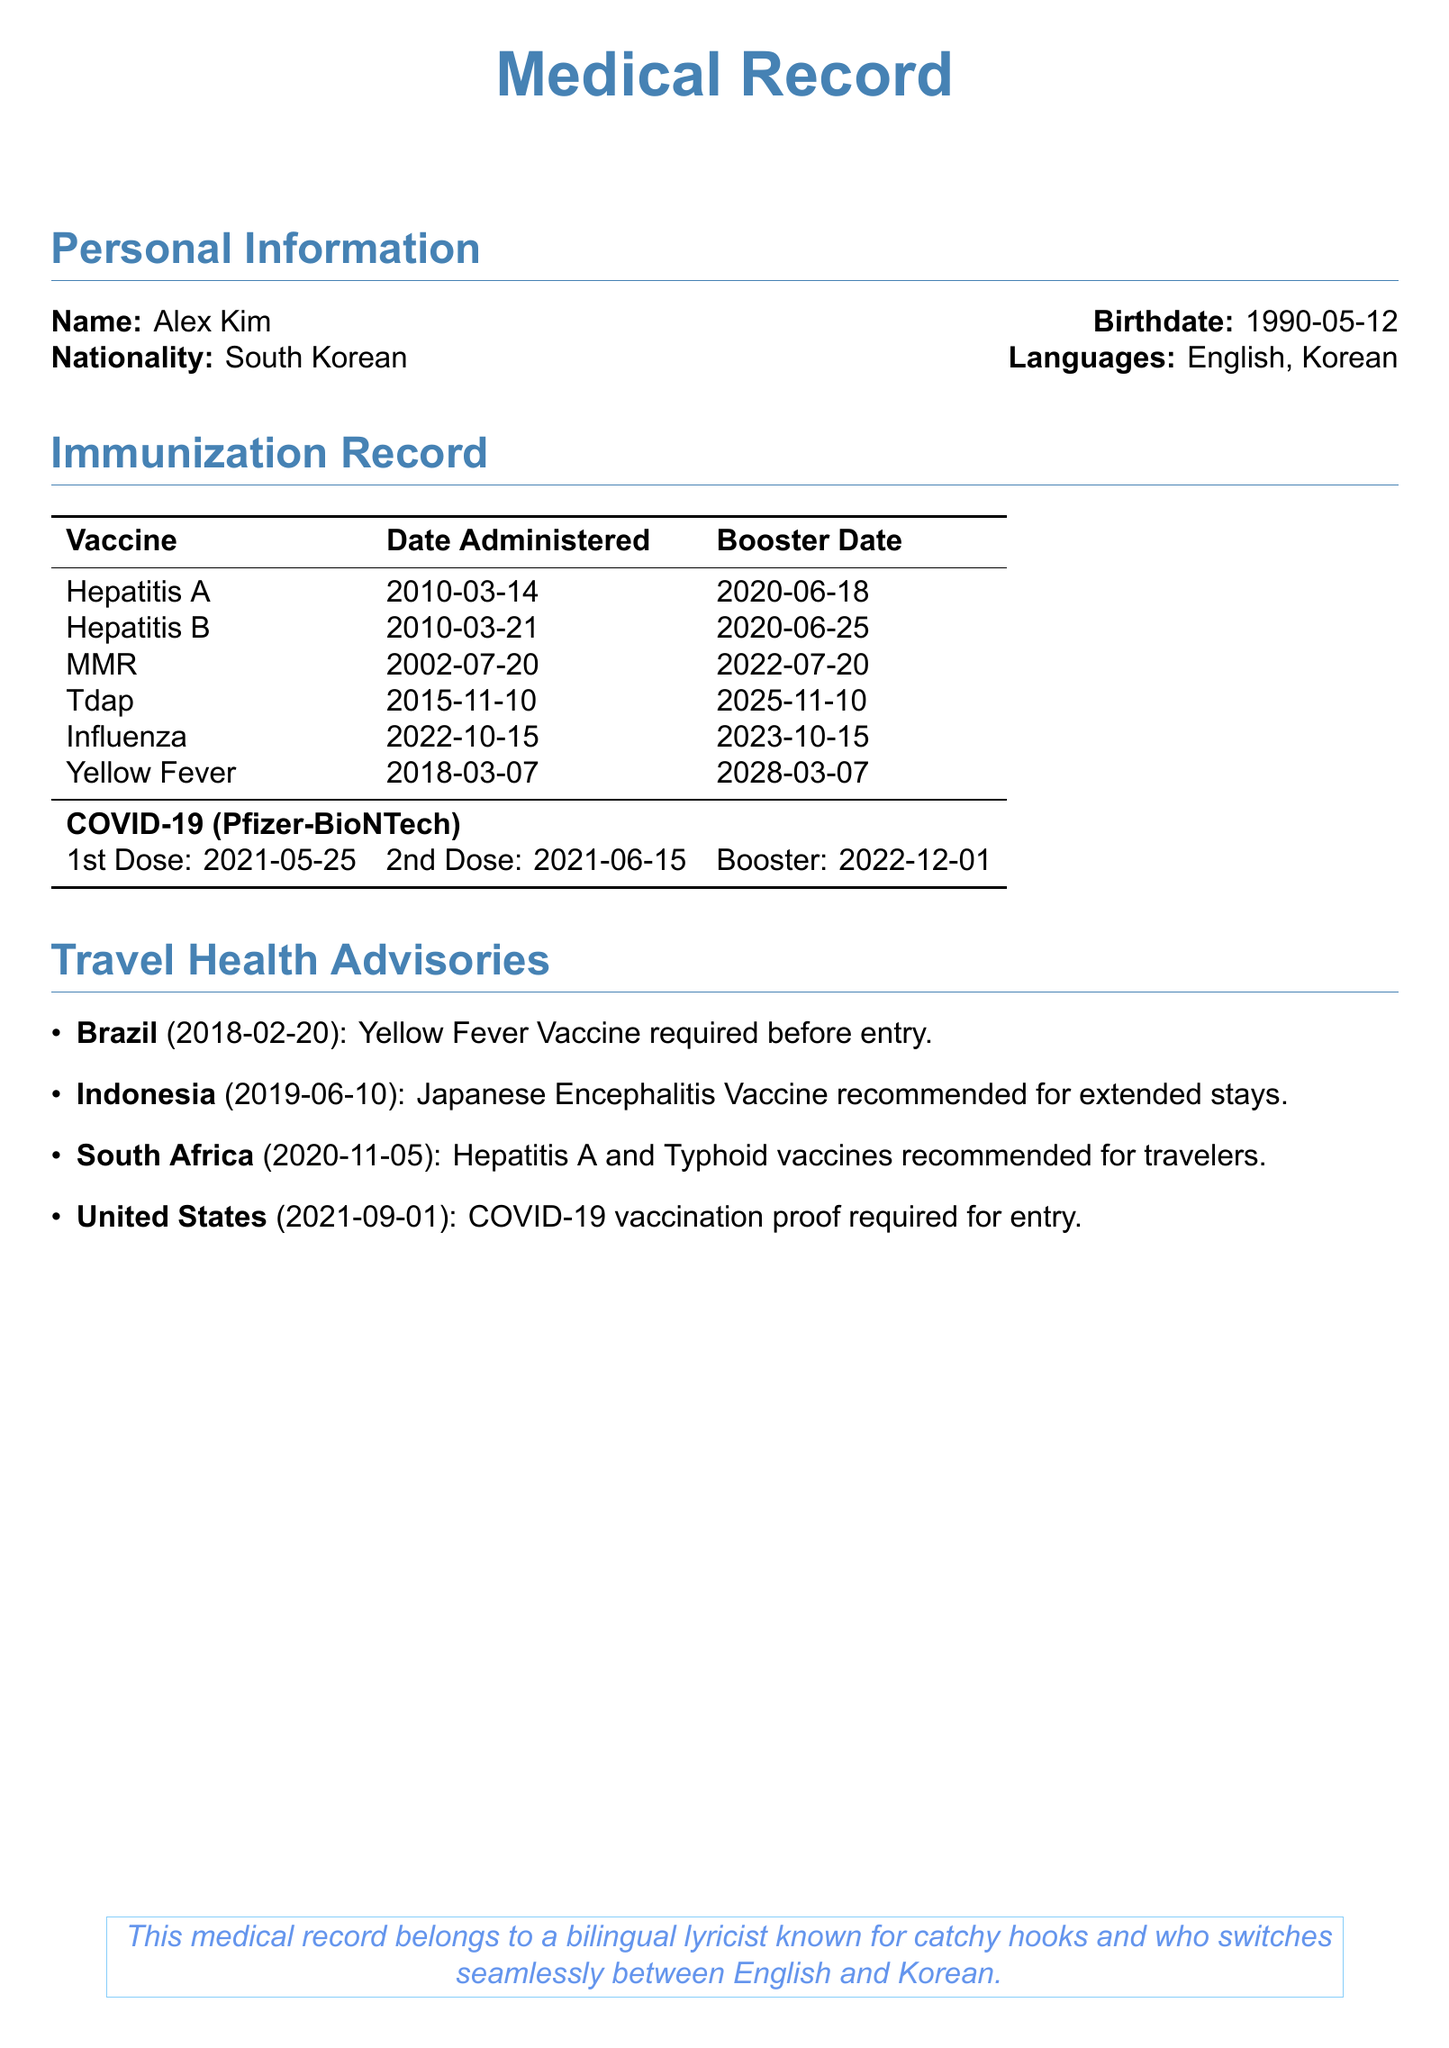What is the full name of the individual? The document provides the personal information, including the individual's name, which is Alex Kim.
Answer: Alex Kim What is the birthdate of the individual? The birthdate is listed in the personal information section of the document, which is 1990-05-12.
Answer: 1990-05-12 When was the last Hepatitis B booster administered? The last booster for Hepatitis B is noted in the immunization record with the date 2020-06-25.
Answer: 2020-06-25 Which vaccine requires proof of vaccination for entry into the United States? The travel health advisory mentions that COVID-19 vaccination proof is required for entry into the United States.
Answer: COVID-19 How many doses of the COVID-19 vaccine has the individual received? The document details three doses of the COVID-19 vaccine: 1st dose, 2nd dose, and a booster.
Answer: Three doses What vaccination is required before entering Brazil? The travel health advisory specifies that the Yellow Fever Vaccine is required before entry into Brazil.
Answer: Yellow Fever Vaccine When is the next scheduled Tdap booster? The immunization record provides a scheduled date for the next Tdap booster, which is in 2025-11-10.
Answer: 2025-11-10 Which vaccine is recommended for extended stays in Indonesia? According to the travel health advisories, the Japanese Encephalitis Vaccine is recommended for extended stays in Indonesia.
Answer: Japanese Encephalitis Vaccine 